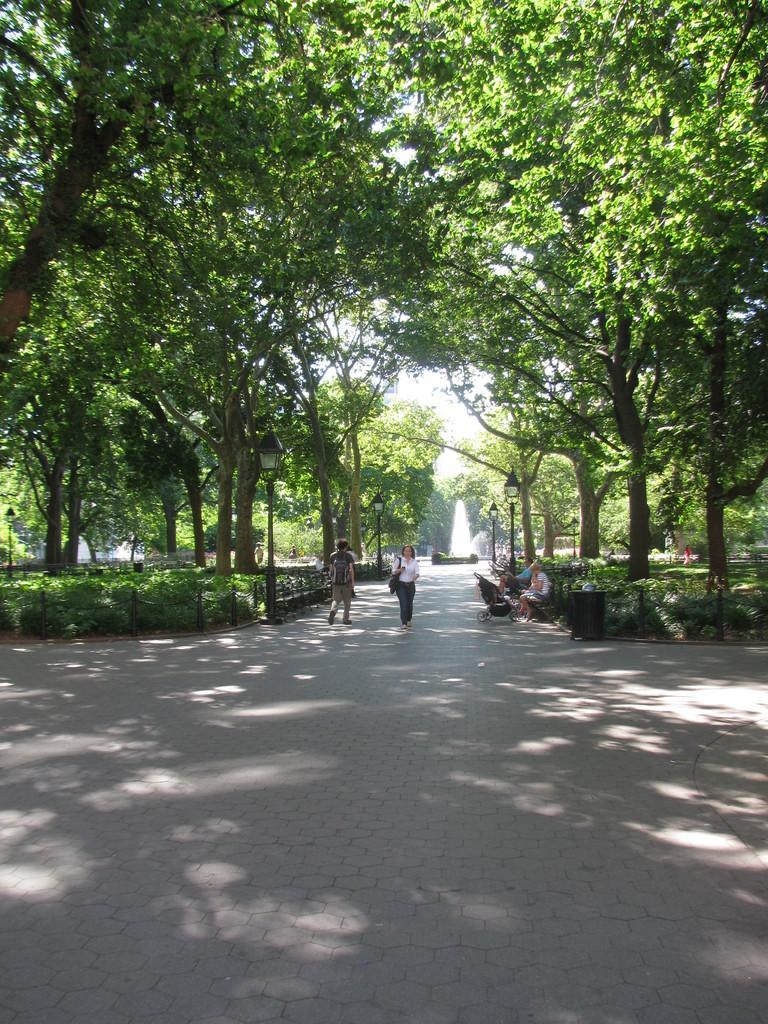Can you describe this image briefly? The picture is taken in a park. In the foreground of the picture it is payment. In the center of the background there are people, benches, fountain and trees. On the right there are trees. On the left there are trees. It is sunny. 